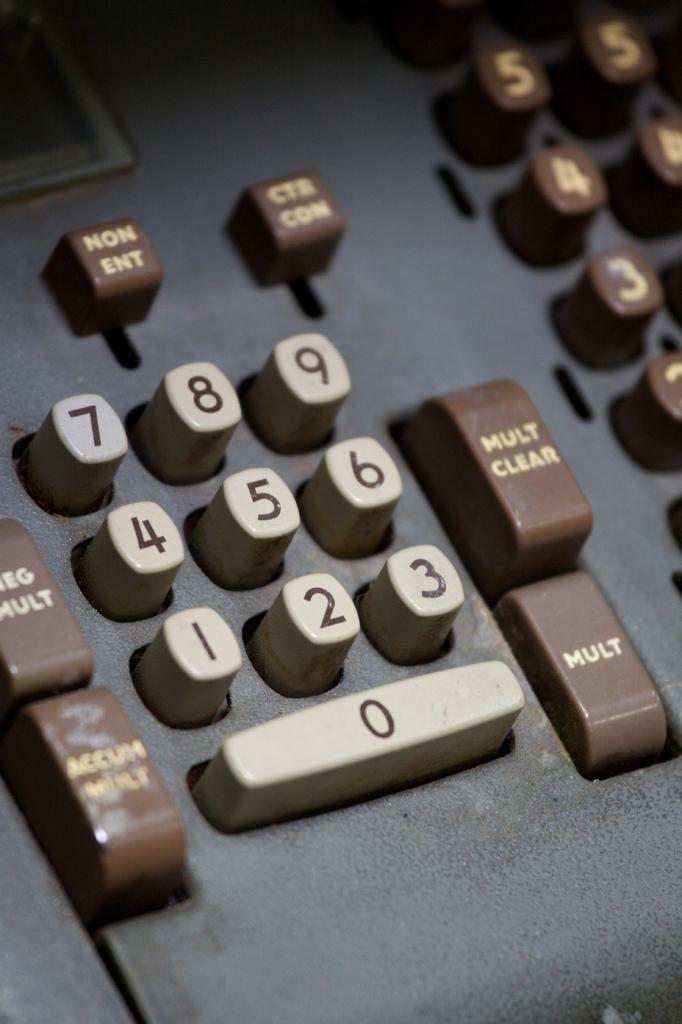<image>
Describe the image concisely. A number pad of buttons including Mult and Mult Clear 